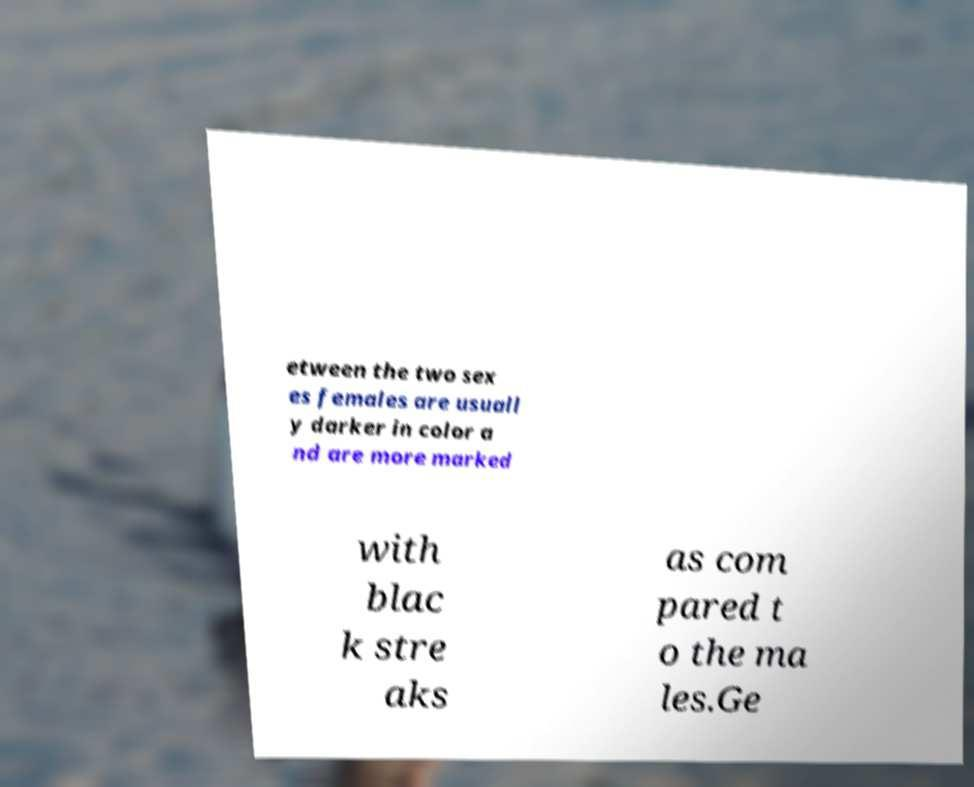What messages or text are displayed in this image? I need them in a readable, typed format. etween the two sex es females are usuall y darker in color a nd are more marked with blac k stre aks as com pared t o the ma les.Ge 